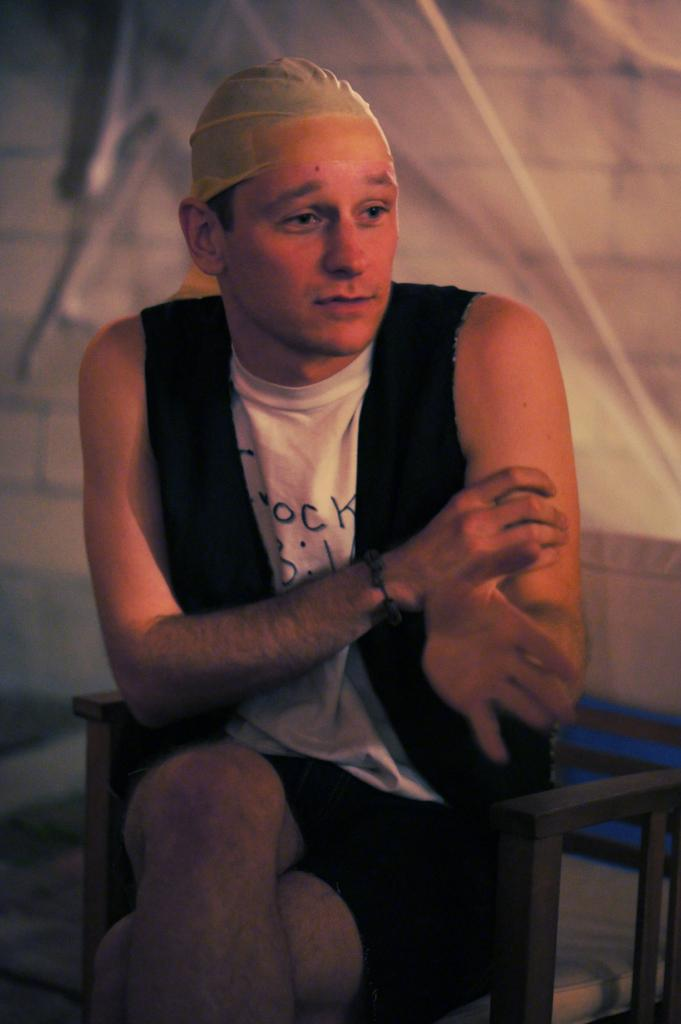What can be seen in the image? There is a person in the image. What is the person wearing? The person is wearing a white and black top. What is the person doing in the image? The person is sitting. What is on the person's head? There is an object on the person's head. What can be seen in the background of the image? There is a white cloth attached to the wall in the background. What is the person discussing with others in the image? There is no indication of a discussion or other people present in the image. --- Facts: 1. There is a car in the image. 2. The car is red. 3. The car has four wheels. 4. There is a person standing next to the car. 5. The person is holding a key. Absurd Topics: parrot, piano, Conversation: What is the main subject in the image? There is a car in the image. What color is the car? The car is red. How many wheels does the car have? The car has four wheels. Is there anyone else in the image besides the car? Yes, there is a person standing next to the car. What is the person doing in the image? The person is holding a key. Reasoning: Let's think step by step in order to ${produce the conversation}. We start by identifying the main subject of the image, which is the car. Next, we describe specific features of the car, such as the color and the number of wheels. Then, we observe the actions of the person in the image, noting that they are holding a key. Absurd Question/Answer: Can you hear the parrot singing in the image? There is no parrot present in the image. --- Facts: 1. There is a group of people in the image. 2. The people are wearing costumes. 3. The costumes are related to a specific theme. 4. The background of the image is a park. Absurd Topics: elephant, elephant ride Conversation: How many people are in the image? There is a group of people in the image. What are the people wearing in the image? The people are wearing costumes. What theme are the costumes related to? The costumes are related to a specific theme. Where is the image taken? The background of the image is a park. Reasoning: Let's think step by step in order to ${produce the conversation}. We start by identifying the main subject of the image, which is the group of people. Next, we describe the specific feature of the people, which are the costumes they are wearing. Then, we mention the theme that the costumes are related to. Finally, we describe the background of the image, which is a park. 